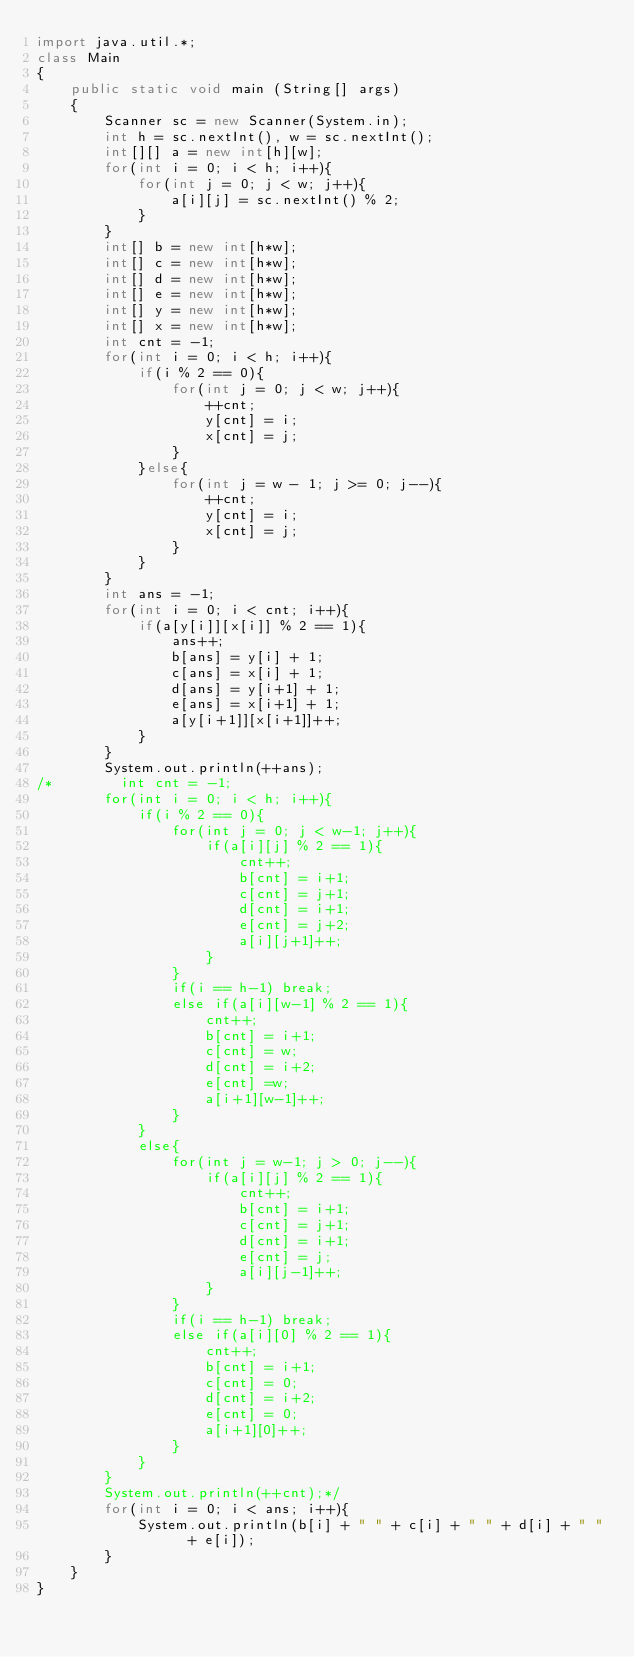<code> <loc_0><loc_0><loc_500><loc_500><_Java_>import java.util.*;
class Main
{
    public static void main (String[] args)
    {
        Scanner sc = new Scanner(System.in);
        int h = sc.nextInt(), w = sc.nextInt();
        int[][] a = new int[h][w];
        for(int i = 0; i < h; i++){
            for(int j = 0; j < w; j++){
                a[i][j] = sc.nextInt() % 2;
            }
        }
        int[] b = new int[h*w];
        int[] c = new int[h*w];
        int[] d = new int[h*w];
        int[] e = new int[h*w];
        int[] y = new int[h*w];
        int[] x = new int[h*w];
        int cnt = -1;
        for(int i = 0; i < h; i++){
            if(i % 2 == 0){
                for(int j = 0; j < w; j++){
                    ++cnt;
                    y[cnt] = i;
                    x[cnt] = j;  
                }
            }else{
                for(int j = w - 1; j >= 0; j--){
                    ++cnt;
                    y[cnt] = i;
                    x[cnt] = j;
                } 
            }
        }
        int ans = -1;
        for(int i = 0; i < cnt; i++){
            if(a[y[i]][x[i]] % 2 == 1){
                ans++;
                b[ans] = y[i] + 1;
                c[ans] = x[i] + 1;
                d[ans] = y[i+1] + 1;
                e[ans] = x[i+1] + 1;
                a[y[i+1]][x[i+1]]++;
            }
        }
        System.out.println(++ans);
/*        int cnt = -1;
        for(int i = 0; i < h; i++){
            if(i % 2 == 0){
                for(int j = 0; j < w-1; j++){
                    if(a[i][j] % 2 == 1){
                        cnt++;
                        b[cnt] = i+1;
                        c[cnt] = j+1;
                        d[cnt] = i+1;
                        e[cnt] = j+2;
                        a[i][j+1]++;
                    }
                }
                if(i == h-1) break;
                else if(a[i][w-1] % 2 == 1){
                    cnt++;
                    b[cnt] = i+1;
                    c[cnt] = w;
                    d[cnt] = i+2;
                    e[cnt] =w;
                    a[i+1][w-1]++;
                }
            }
            else{
                for(int j = w-1; j > 0; j--){
                    if(a[i][j] % 2 == 1){
                        cnt++;
                        b[cnt] = i+1;
                        c[cnt] = j+1;
                        d[cnt] = i+1;
                        e[cnt] = j;
                        a[i][j-1]++;
                    }
                }
                if(i == h-1) break;
                else if(a[i][0] % 2 == 1){
                    cnt++;
                    b[cnt] = i+1;
                    c[cnt] = 0;
                    d[cnt] = i+2;
                    e[cnt] = 0; 
                    a[i+1][0]++;
                }
            }
        }
        System.out.println(++cnt);*/
        for(int i = 0; i < ans; i++){
            System.out.println(b[i] + " " + c[i] + " " + d[i] + " "  + e[i]);
        }
    }
}


</code> 